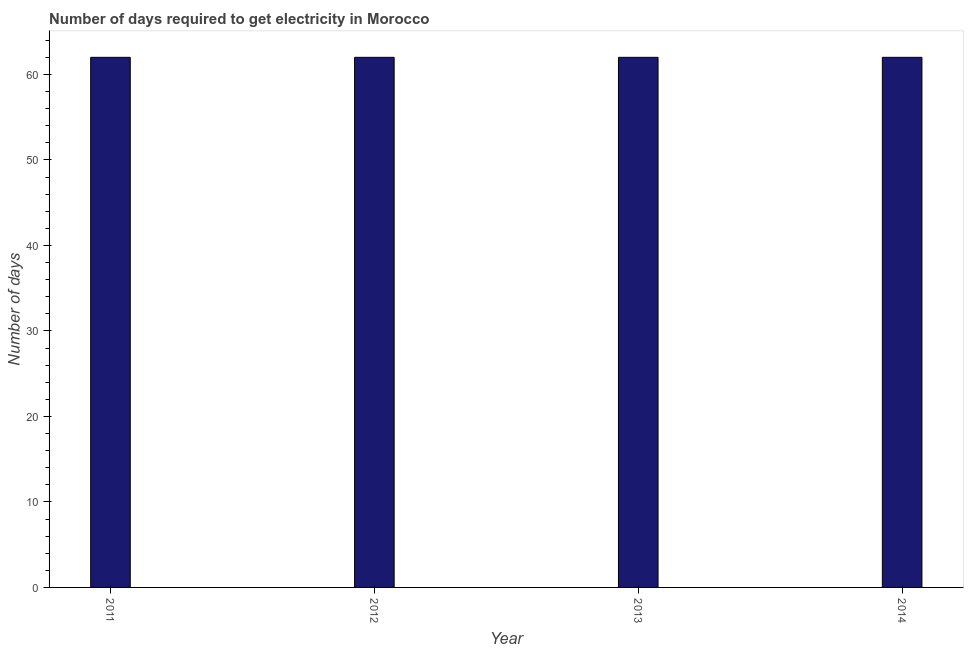Does the graph contain any zero values?
Provide a short and direct response. No. Does the graph contain grids?
Make the answer very short. No. What is the title of the graph?
Provide a short and direct response. Number of days required to get electricity in Morocco. What is the label or title of the Y-axis?
Your response must be concise. Number of days. What is the time to get electricity in 2014?
Your response must be concise. 62. Across all years, what is the minimum time to get electricity?
Offer a terse response. 62. In which year was the time to get electricity minimum?
Your answer should be compact. 2011. What is the sum of the time to get electricity?
Make the answer very short. 248. What is the difference between the time to get electricity in 2012 and 2014?
Make the answer very short. 0. What is the median time to get electricity?
Provide a succinct answer. 62. What is the ratio of the time to get electricity in 2013 to that in 2014?
Offer a terse response. 1. Is the time to get electricity in 2013 less than that in 2014?
Offer a very short reply. No. What is the difference between the highest and the second highest time to get electricity?
Provide a succinct answer. 0. In how many years, is the time to get electricity greater than the average time to get electricity taken over all years?
Your answer should be compact. 0. How many bars are there?
Offer a terse response. 4. Are all the bars in the graph horizontal?
Offer a terse response. No. How many years are there in the graph?
Your answer should be compact. 4. What is the Number of days of 2013?
Offer a very short reply. 62. What is the difference between the Number of days in 2011 and 2013?
Offer a very short reply. 0. What is the difference between the Number of days in 2012 and 2013?
Give a very brief answer. 0. What is the ratio of the Number of days in 2011 to that in 2012?
Your response must be concise. 1. What is the ratio of the Number of days in 2012 to that in 2014?
Ensure brevity in your answer.  1. 